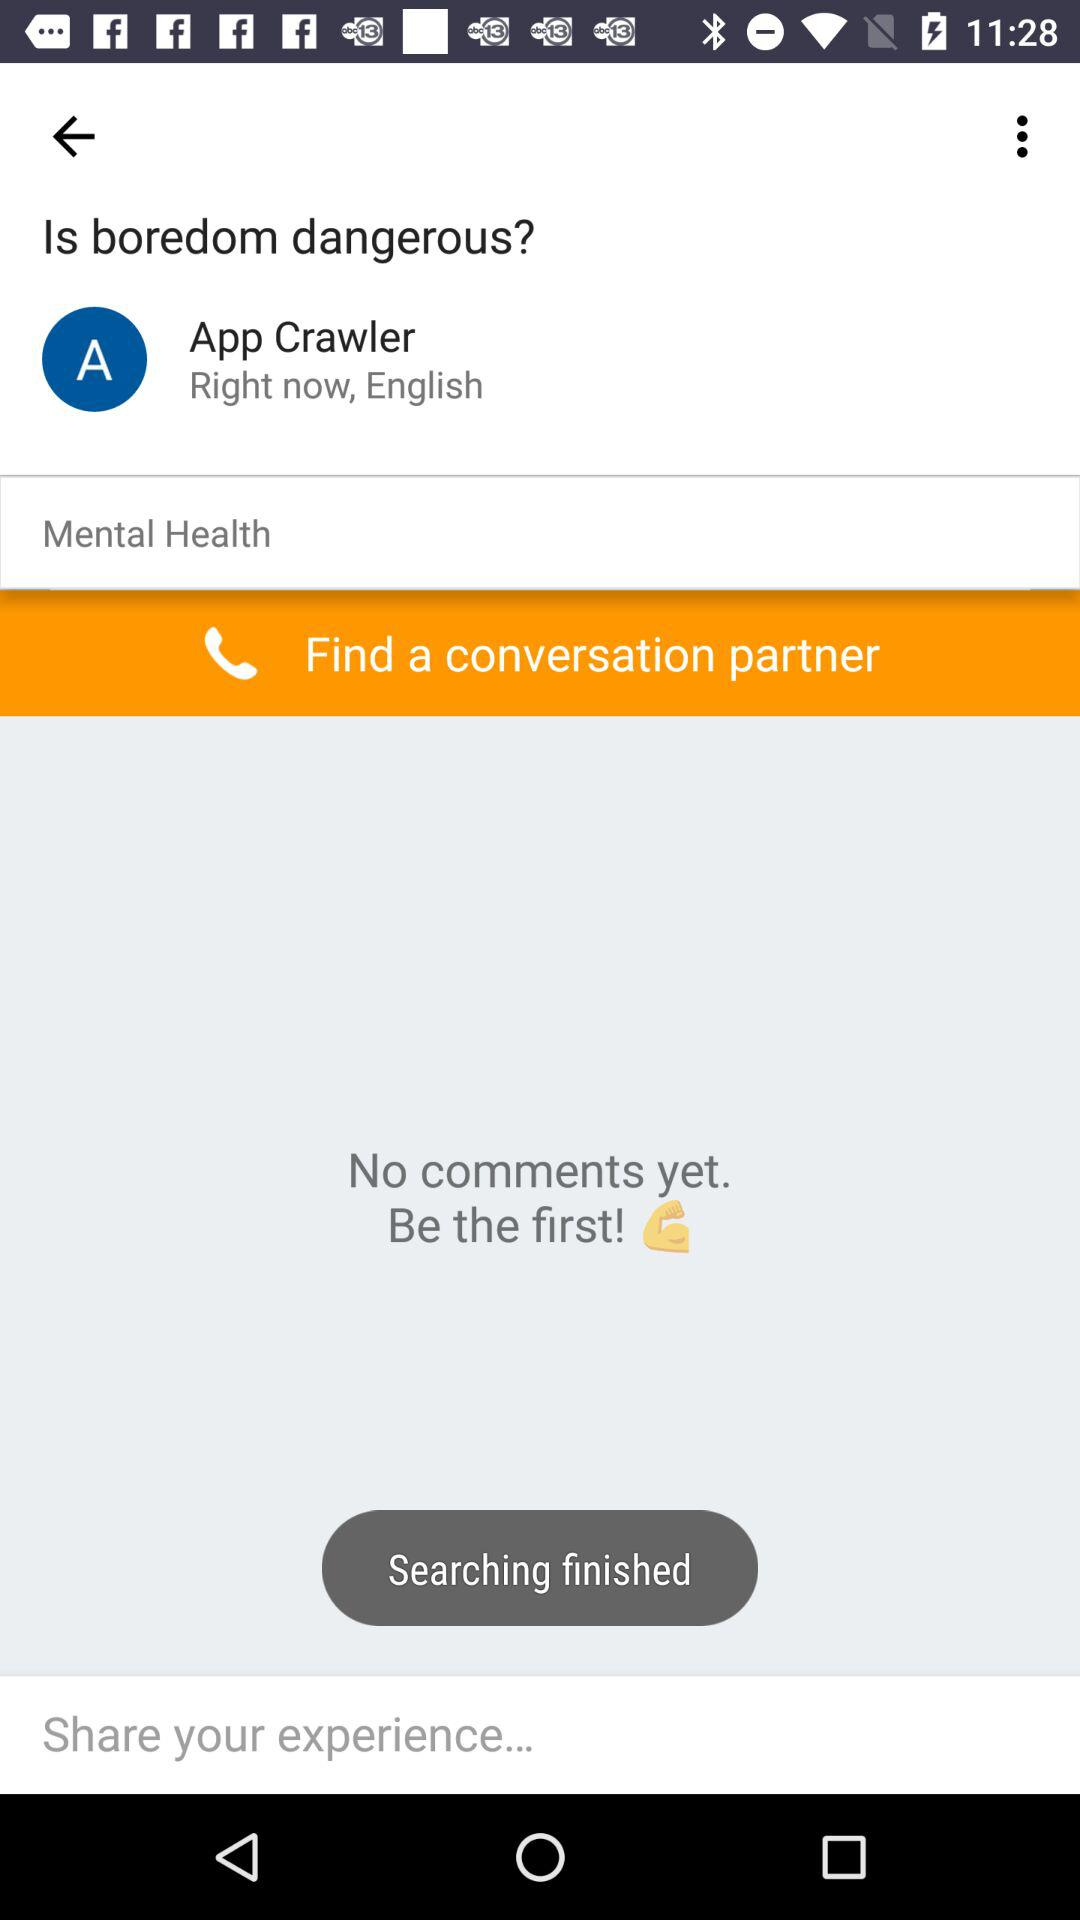How many comments are there? 0 